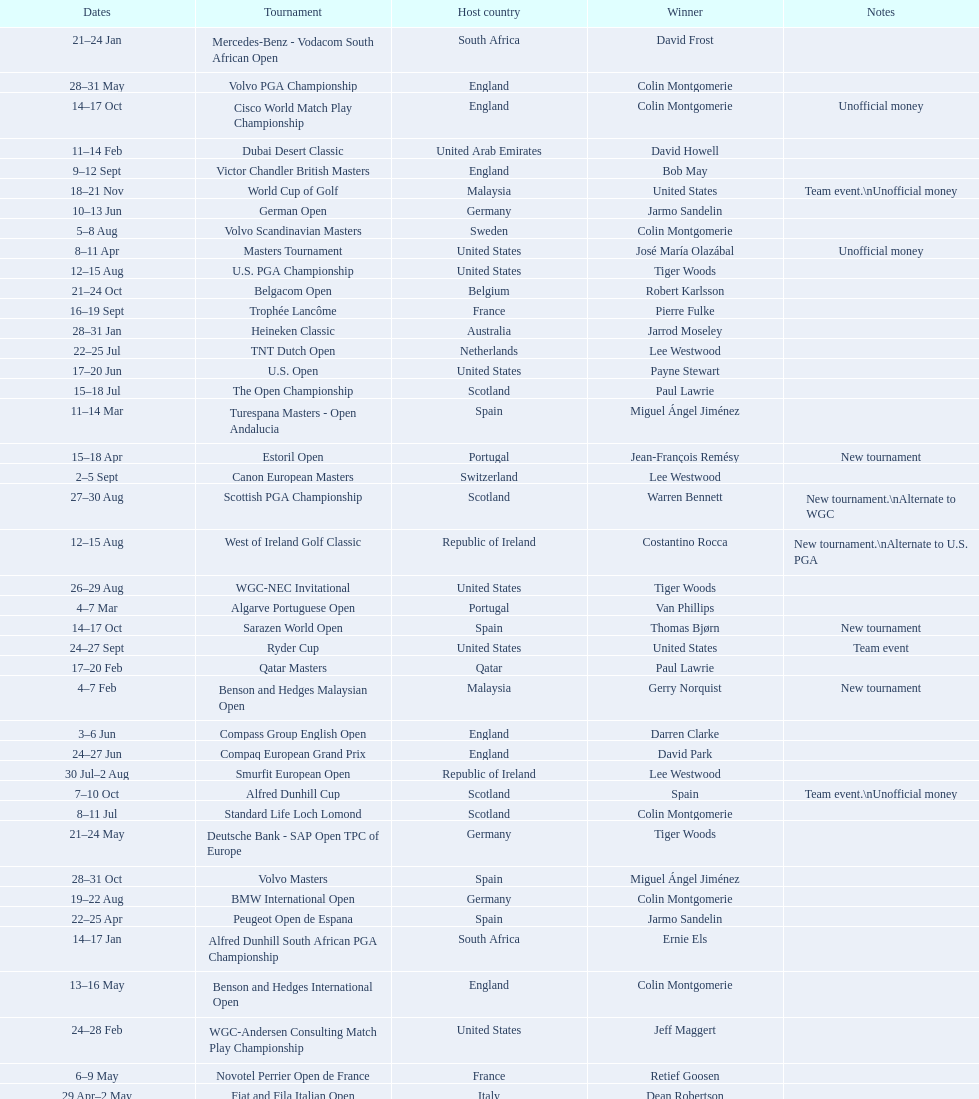Does any country have more than 5 winners? Yes. Give me the full table as a dictionary. {'header': ['Dates', 'Tournament', 'Host country', 'Winner', 'Notes'], 'rows': [['21–24\xa0Jan', 'Mercedes-Benz - Vodacom South African Open', 'South Africa', 'David Frost', ''], ['28–31\xa0May', 'Volvo PGA Championship', 'England', 'Colin Montgomerie', ''], ['14–17\xa0Oct', 'Cisco World Match Play Championship', 'England', 'Colin Montgomerie', 'Unofficial money'], ['11–14\xa0Feb', 'Dubai Desert Classic', 'United Arab Emirates', 'David Howell', ''], ['9–12\xa0Sept', 'Victor Chandler British Masters', 'England', 'Bob May', ''], ['18–21\xa0Nov', 'World Cup of Golf', 'Malaysia', 'United States', 'Team event.\\nUnofficial money'], ['10–13\xa0Jun', 'German Open', 'Germany', 'Jarmo Sandelin', ''], ['5–8\xa0Aug', 'Volvo Scandinavian Masters', 'Sweden', 'Colin Montgomerie', ''], ['8–11\xa0Apr', 'Masters Tournament', 'United States', 'José María Olazábal', 'Unofficial money'], ['12–15\xa0Aug', 'U.S. PGA Championship', 'United States', 'Tiger Woods', ''], ['21–24\xa0Oct', 'Belgacom Open', 'Belgium', 'Robert Karlsson', ''], ['16–19\xa0Sept', 'Trophée Lancôme', 'France', 'Pierre Fulke', ''], ['28–31\xa0Jan', 'Heineken Classic', 'Australia', 'Jarrod Moseley', ''], ['22–25\xa0Jul', 'TNT Dutch Open', 'Netherlands', 'Lee Westwood', ''], ['17–20\xa0Jun', 'U.S. Open', 'United States', 'Payne Stewart', ''], ['15–18\xa0Jul', 'The Open Championship', 'Scotland', 'Paul Lawrie', ''], ['11–14\xa0Mar', 'Turespana Masters - Open Andalucia', 'Spain', 'Miguel Ángel Jiménez', ''], ['15–18\xa0Apr', 'Estoril Open', 'Portugal', 'Jean-François Remésy', 'New tournament'], ['2–5\xa0Sept', 'Canon European Masters', 'Switzerland', 'Lee Westwood', ''], ['27–30\xa0Aug', 'Scottish PGA Championship', 'Scotland', 'Warren Bennett', 'New tournament.\\nAlternate to WGC'], ['12–15\xa0Aug', 'West of Ireland Golf Classic', 'Republic of Ireland', 'Costantino Rocca', 'New tournament.\\nAlternate to U.S. PGA'], ['26–29\xa0Aug', 'WGC-NEC Invitational', 'United States', 'Tiger Woods', ''], ['4–7\xa0Mar', 'Algarve Portuguese Open', 'Portugal', 'Van Phillips', ''], ['14–17\xa0Oct', 'Sarazen World Open', 'Spain', 'Thomas Bjørn', 'New tournament'], ['24–27\xa0Sept', 'Ryder Cup', 'United States', 'United States', 'Team event'], ['17–20\xa0Feb', 'Qatar Masters', 'Qatar', 'Paul Lawrie', ''], ['4–7\xa0Feb', 'Benson and Hedges Malaysian Open', 'Malaysia', 'Gerry Norquist', 'New tournament'], ['3–6\xa0Jun', 'Compass Group English Open', 'England', 'Darren Clarke', ''], ['24–27\xa0Jun', 'Compaq European Grand Prix', 'England', 'David Park', ''], ['30\xa0Jul–2\xa0Aug', 'Smurfit European Open', 'Republic of Ireland', 'Lee Westwood', ''], ['7–10\xa0Oct', 'Alfred Dunhill Cup', 'Scotland', 'Spain', 'Team event.\\nUnofficial money'], ['8–11\xa0Jul', 'Standard Life Loch Lomond', 'Scotland', 'Colin Montgomerie', ''], ['21–24\xa0May', 'Deutsche Bank - SAP Open TPC of Europe', 'Germany', 'Tiger Woods', ''], ['28–31\xa0Oct', 'Volvo Masters', 'Spain', 'Miguel Ángel Jiménez', ''], ['19–22\xa0Aug', 'BMW International Open', 'Germany', 'Colin Montgomerie', ''], ['22–25\xa0Apr', 'Peugeot Open de Espana', 'Spain', 'Jarmo Sandelin', ''], ['14–17\xa0Jan', 'Alfred Dunhill South African PGA Championship', 'South Africa', 'Ernie Els', ''], ['13–16\xa0May', 'Benson and Hedges International Open', 'England', 'Colin Montgomerie', ''], ['24–28\xa0Feb', 'WGC-Andersen Consulting Match Play Championship', 'United States', 'Jeff Maggert', ''], ['6–9\xa0May', 'Novotel Perrier Open de France', 'France', 'Retief Goosen', ''], ['29\xa0Apr–2\xa0May', 'Fiat and Fila Italian Open', 'Italy', 'Dean Robertson', ''], ['4–7\xa0Nov', 'WGC-American Express Championship', 'Spain', 'Tiger Woods', ''], ['17–20\xa0Jun', 'Moroccan Open', 'Morocco', 'Miguel Ángel Martín', ''], ['25–28\xa0Mar', 'Madeira Island Open', 'Portugal', 'Pedro Linhart', ''], ['30\xa0Sept–3\xa0Oct', 'Linde German Masters', 'Germany', 'Sergio García', ''], ['1–4\xa0Jul', "Murphy's Irish Open", 'Republic of Ireland', 'Sergio García', '']]} 